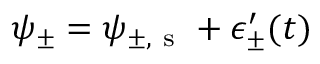Convert formula to latex. <formula><loc_0><loc_0><loc_500><loc_500>\psi _ { \pm } = \psi _ { \pm , s } + \epsilon _ { \pm } ^ { \prime } ( t )</formula> 